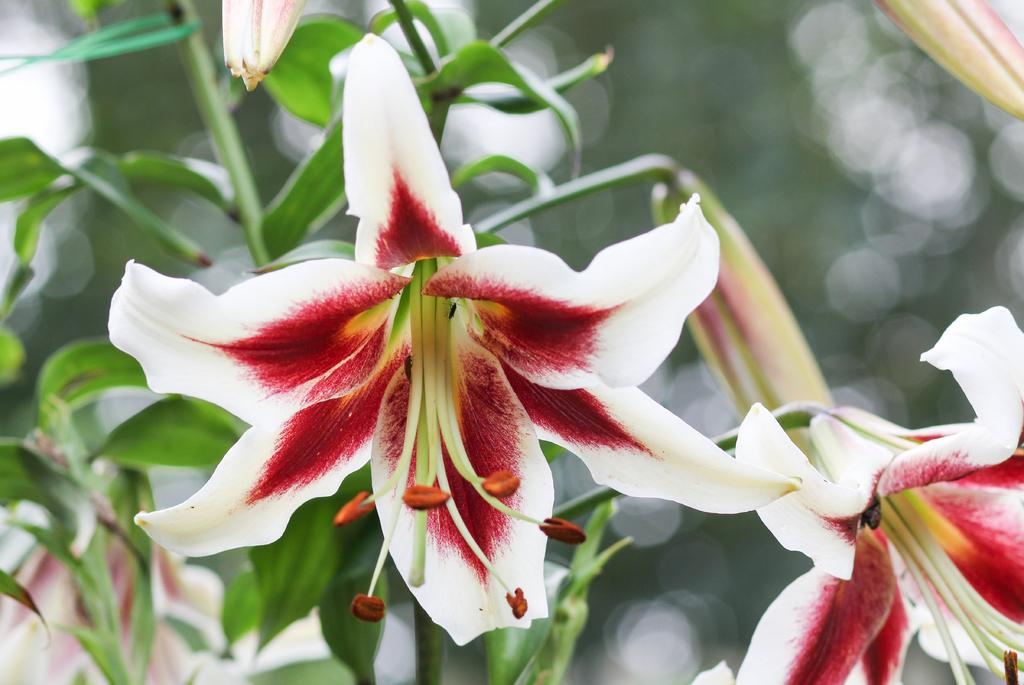What type of living organisms are present in the image? There are flowers in the image. What colors can be seen on the flowers? The flowers have cream, red, and green colors. What color are the plants in the image? The plants in the image are green. How would you describe the background of the image? The background of the image is blurry and has a green color. What type of society do the flowers belong to in the image? The flowers do not belong to any society in the image; they are simply plants. 